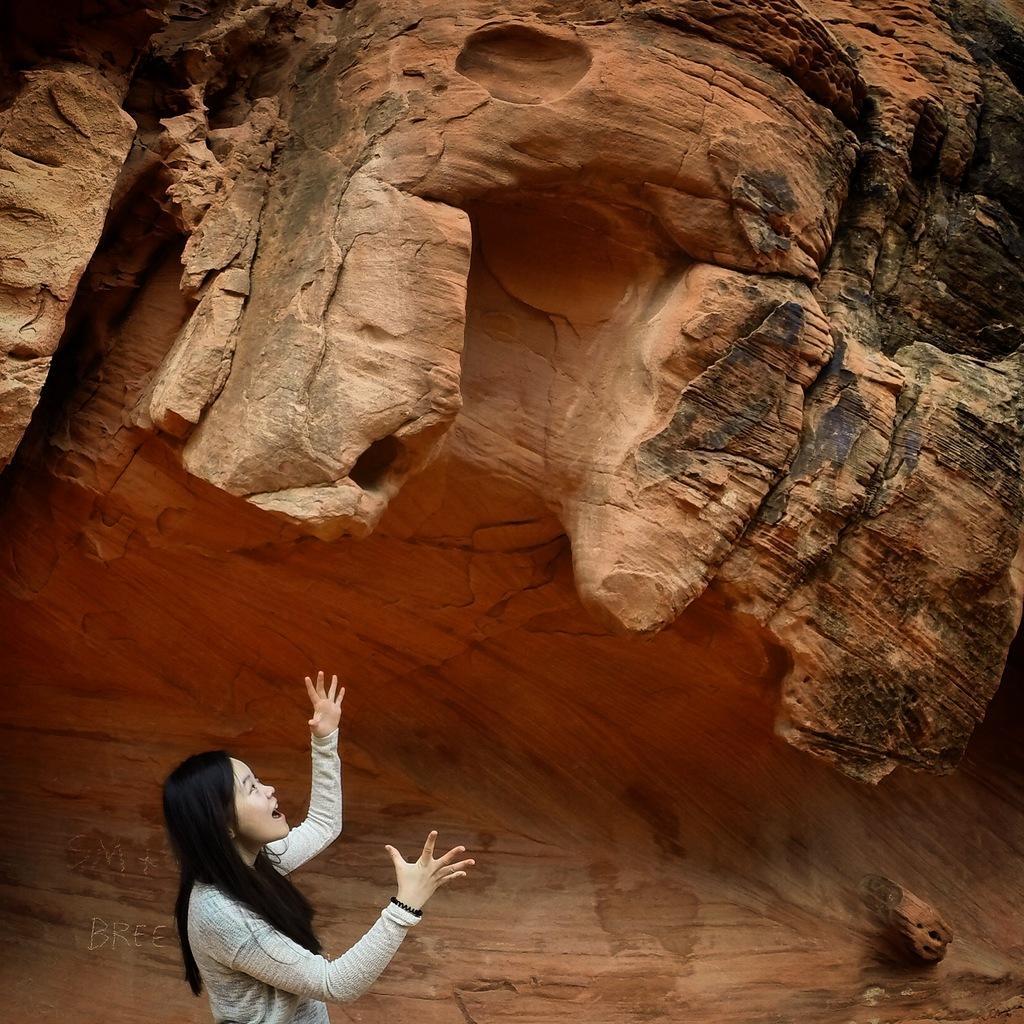How would you summarize this image in a sentence or two? In this image we can see a girl. In the back there is canyon. Also there is a word on the image. 